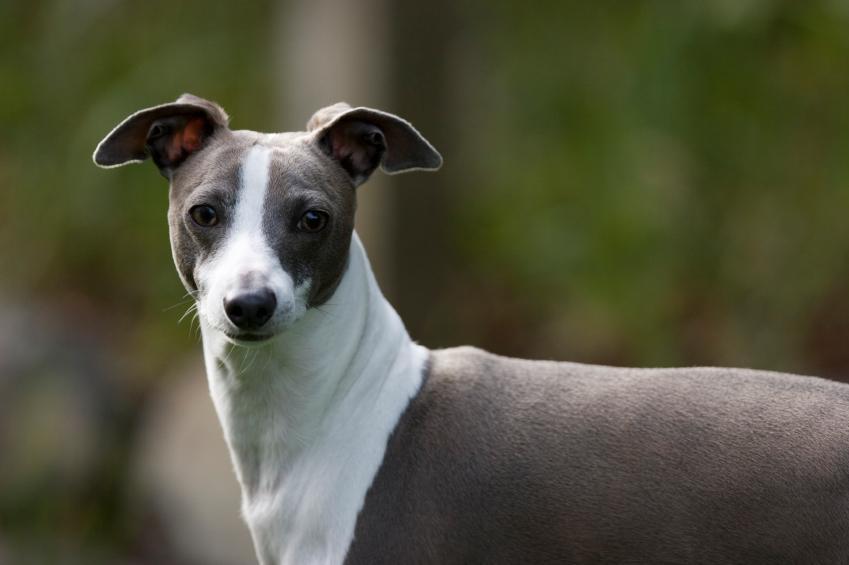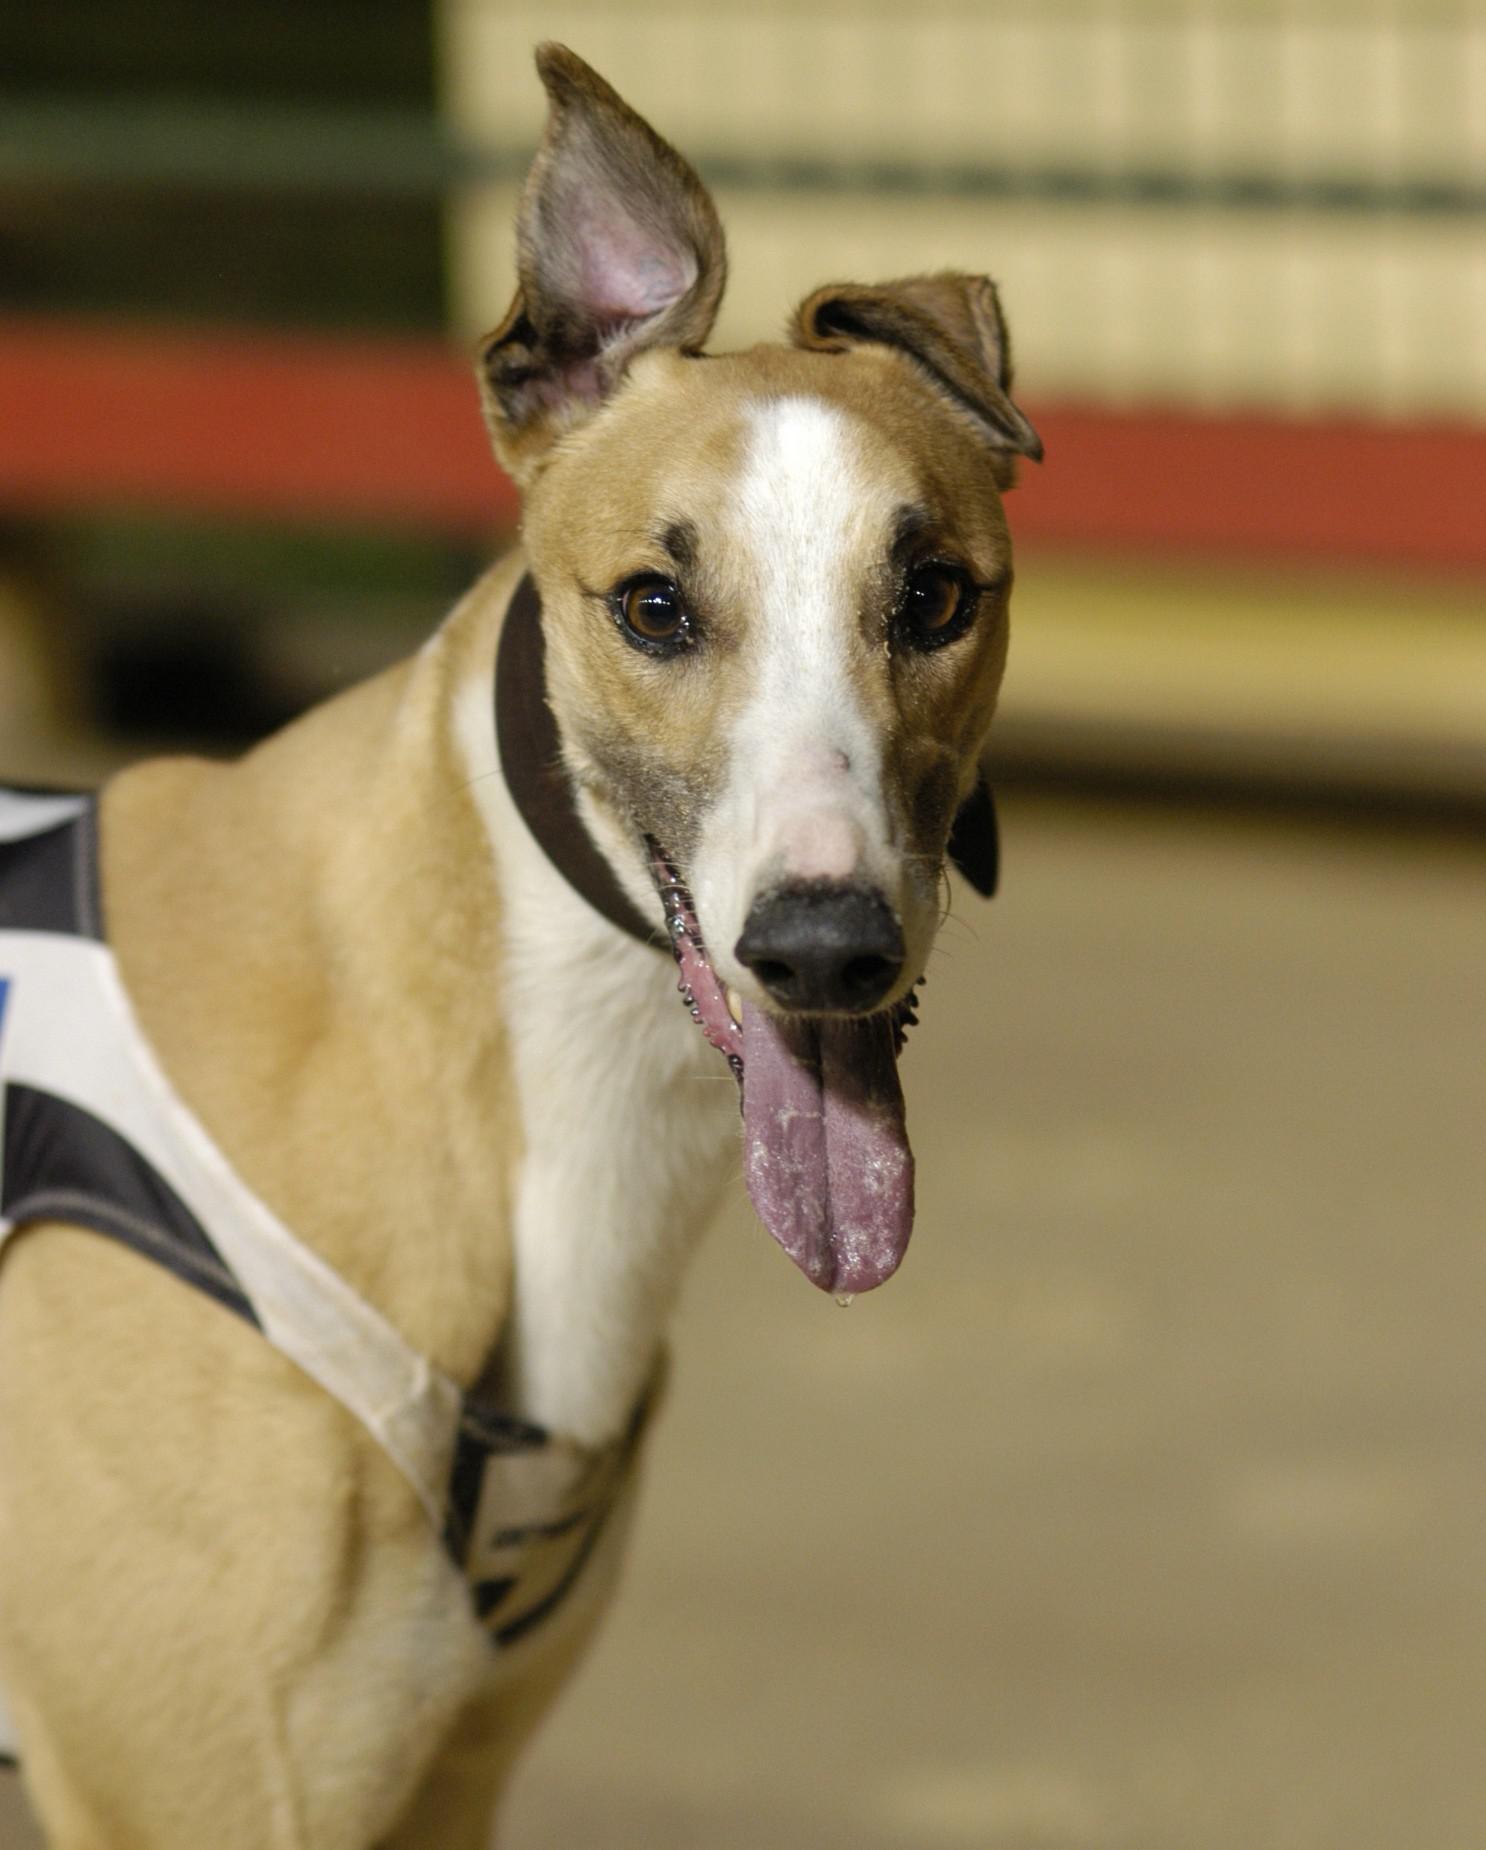The first image is the image on the left, the second image is the image on the right. Considering the images on both sides, is "The dog in the image on the right is standing in profile with its head turned toward the camera." valid? Answer yes or no. Yes. 